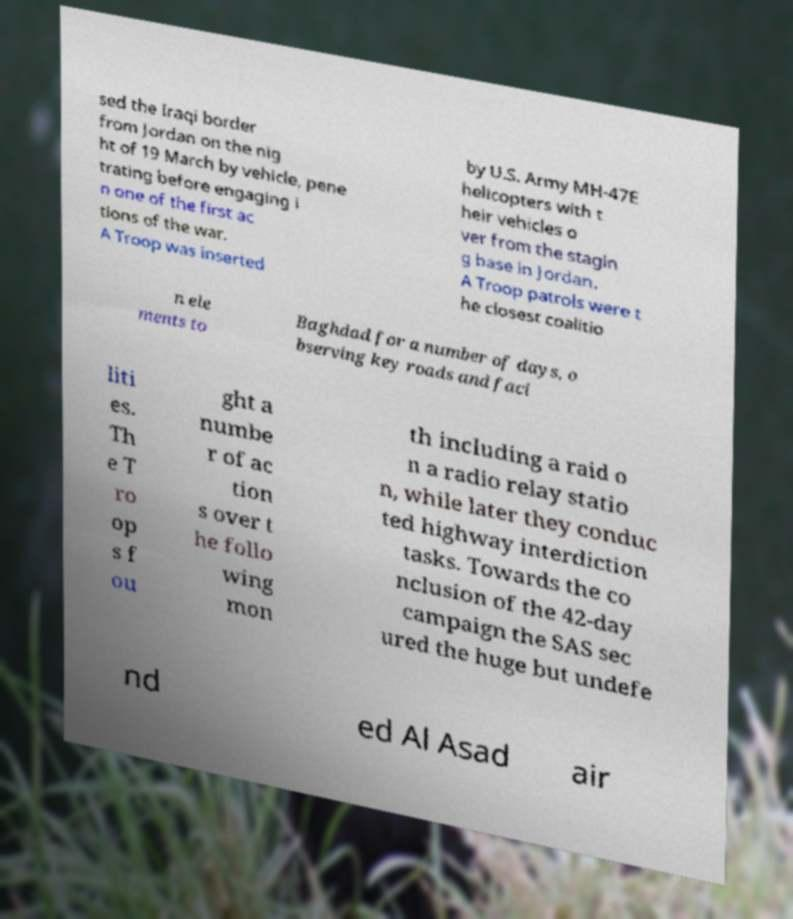Could you extract and type out the text from this image? sed the Iraqi border from Jordan on the nig ht of 19 March by vehicle, pene trating before engaging i n one of the first ac tions of the war. A Troop was inserted by U.S. Army MH-47E helicopters with t heir vehicles o ver from the stagin g base in Jordan. A Troop patrols were t he closest coalitio n ele ments to Baghdad for a number of days, o bserving key roads and faci liti es. Th e T ro op s f ou ght a numbe r of ac tion s over t he follo wing mon th including a raid o n a radio relay statio n, while later they conduc ted highway interdiction tasks. Towards the co nclusion of the 42-day campaign the SAS sec ured the huge but undefe nd ed Al Asad air 